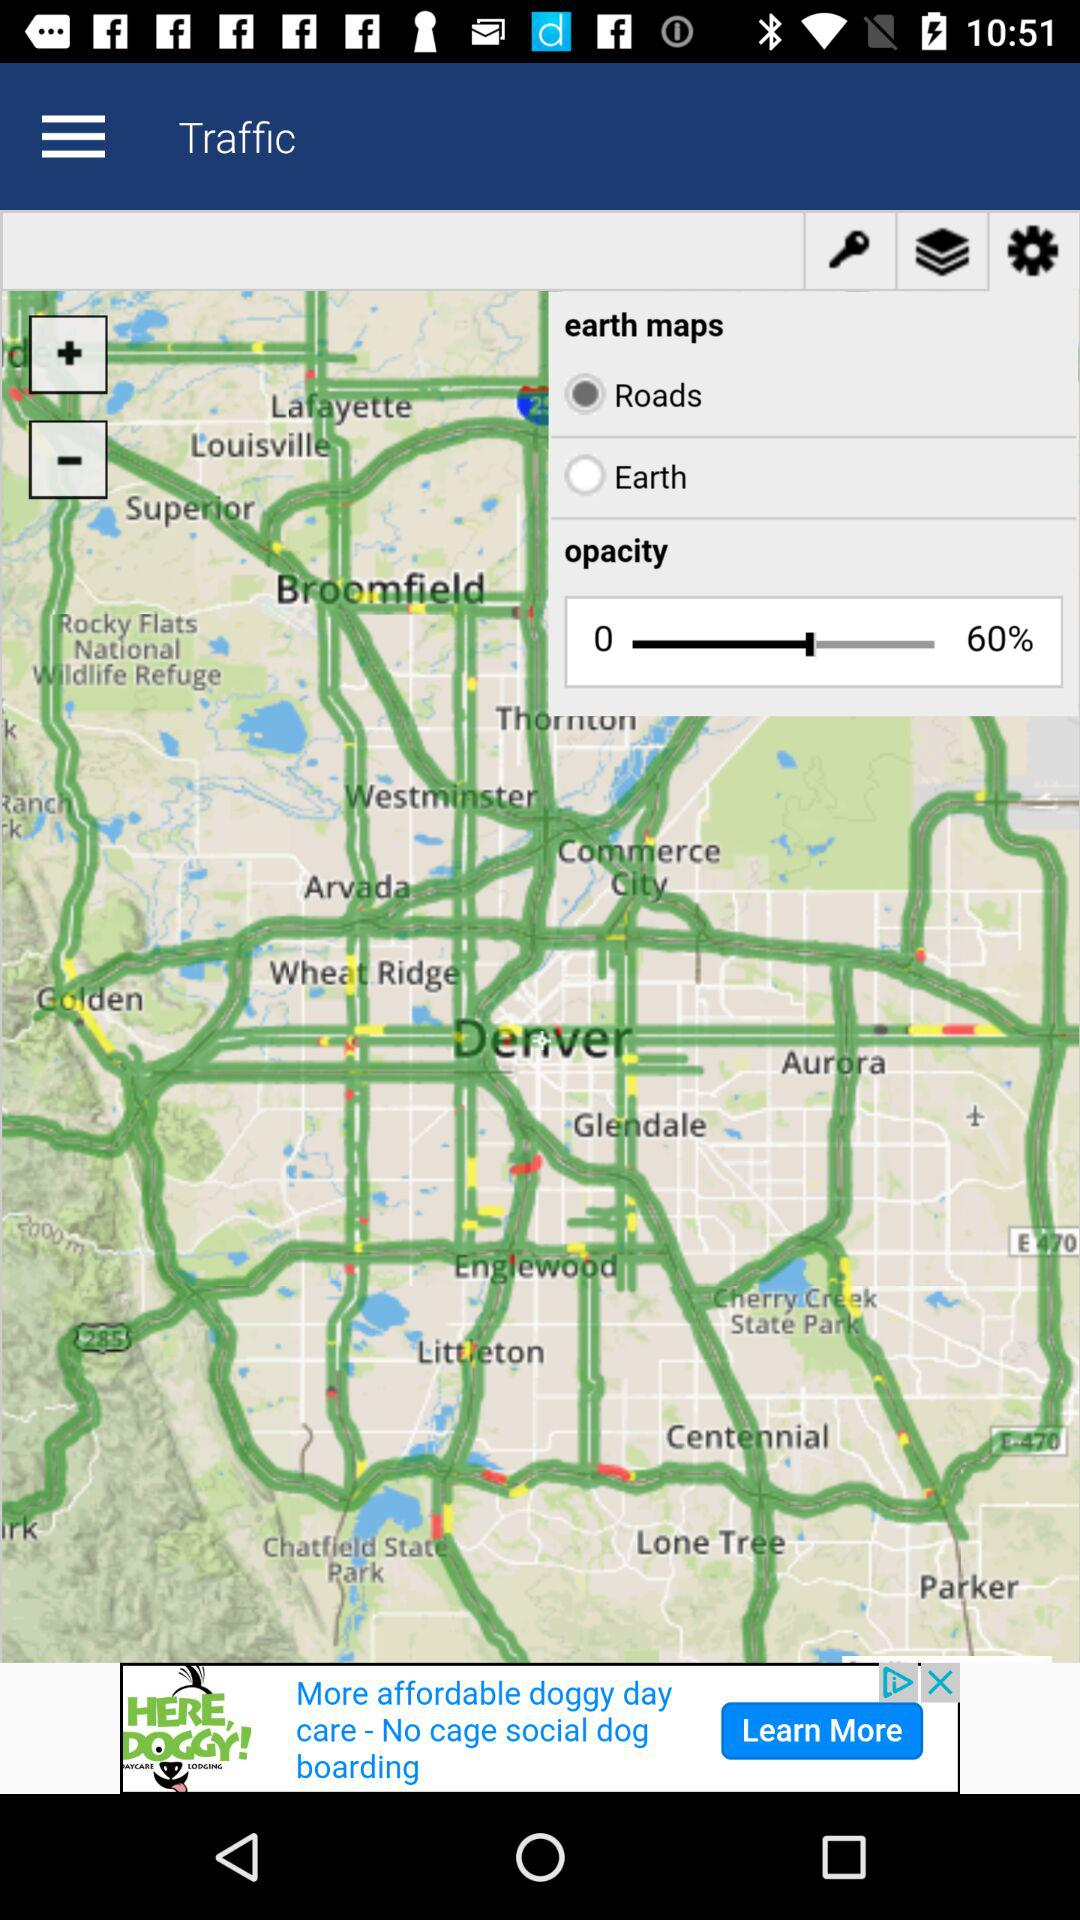What is the given opacity percentage? The given opacity percentage is 60. 